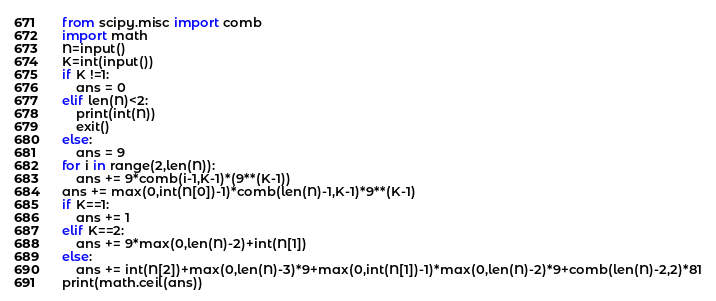Convert code to text. <code><loc_0><loc_0><loc_500><loc_500><_Python_>from scipy.misc import comb
import math
N=input()
K=int(input())
if K !=1:
    ans = 0
elif len(N)<2:
    print(int(N))
    exit()
else:
    ans = 9
for i in range(2,len(N)):
    ans += 9*comb(i-1,K-1)*(9**(K-1))
ans += max(0,int(N[0])-1)*comb(len(N)-1,K-1)*9**(K-1)
if K==1:
    ans += 1
elif K==2:
    ans += 9*max(0,len(N)-2)+int(N[1])
else:
    ans += int(N[2])+max(0,len(N)-3)*9+max(0,int(N[1])-1)*max(0,len(N)-2)*9+comb(len(N)-2,2)*81
print(math.ceil(ans))</code> 